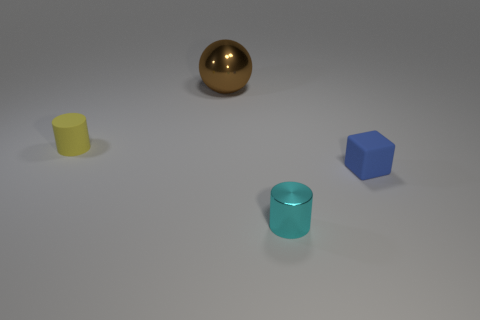How many big objects have the same shape as the tiny blue rubber object?
Provide a succinct answer. 0. There is a blue object that is made of the same material as the yellow cylinder; what size is it?
Provide a short and direct response. Small. What is the color of the object that is both to the right of the yellow cylinder and behind the small blue block?
Provide a short and direct response. Brown. How many green objects have the same size as the matte block?
Your answer should be very brief. 0. How big is the object that is both behind the blue rubber object and in front of the big shiny object?
Give a very brief answer. Small. There is a small cylinder in front of the cylinder left of the large brown thing; how many blue matte cubes are behind it?
Provide a short and direct response. 1. Are there any tiny metallic cylinders that have the same color as the big metallic thing?
Offer a very short reply. No. There is a rubber cube that is the same size as the cyan metallic cylinder; what is its color?
Make the answer very short. Blue. There is a metallic object that is left of the metal thing that is in front of the object that is on the right side of the cyan thing; what shape is it?
Keep it short and to the point. Sphere. What number of brown objects are right of the metallic thing that is behind the yellow object?
Ensure brevity in your answer.  0. 